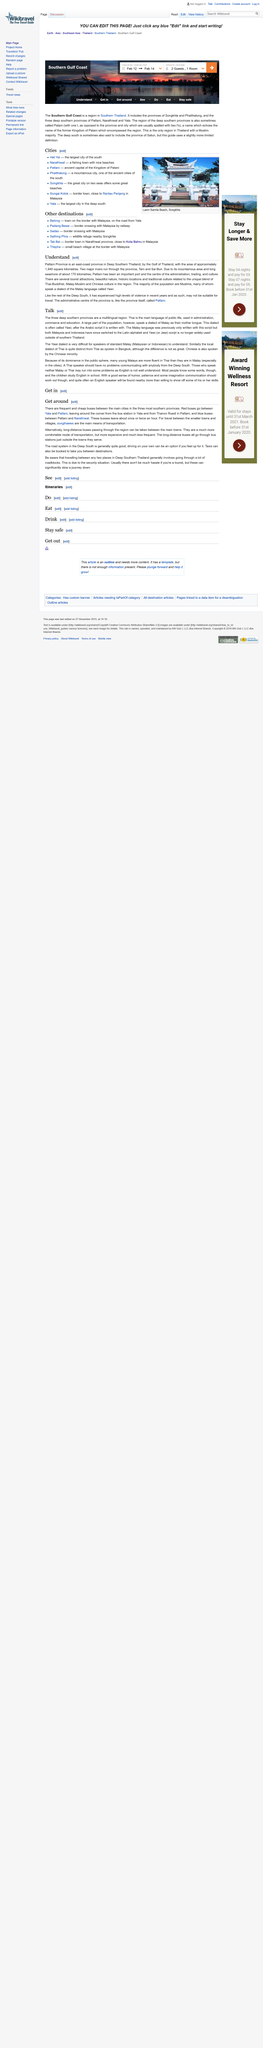Give some essential details in this illustration. The recent years in Deep Southern Thailand have witnessed a significant increase in the level of violence. Pattani is the administrative center of Pattani Province. Pattani Province is located on the eastern coast of Thailand. 